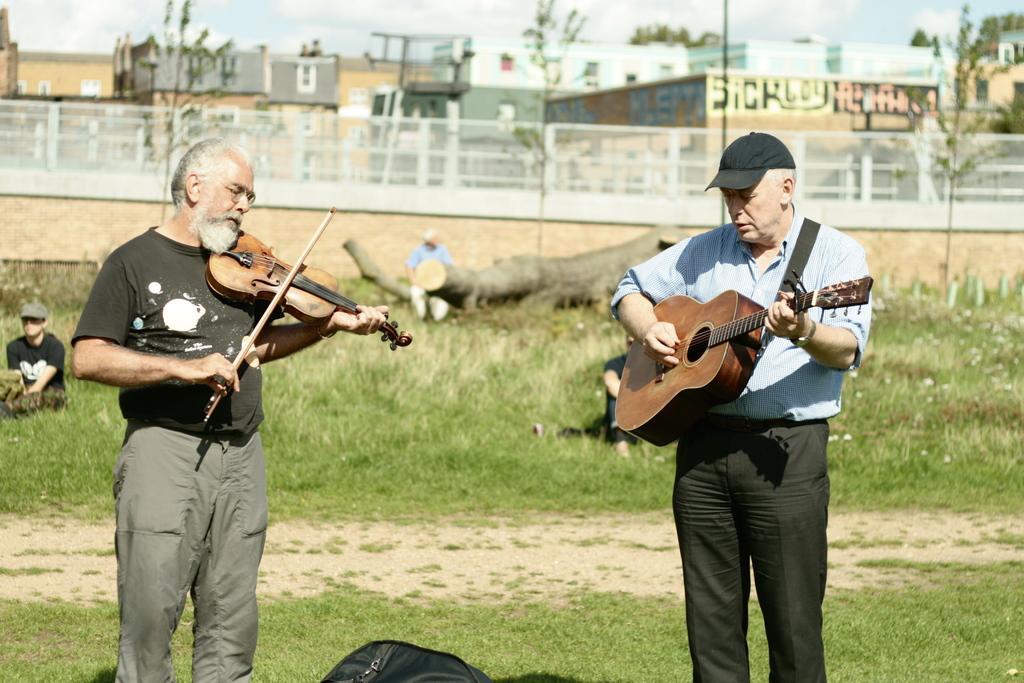In one or two sentences, can you explain what this image depicts? This picture is of outside. On the right there is a man wearing blue color shirt, standing and playing guitar. On the left there is a man wearing black color t-shirt, standing and playing violin. In the background we can see the ground full of grass and the trunk of a tree. There is a person sitting on the trunk of a tree and there is a person wearing black color t-shirt and sitting on the ground and we can see the sky, buildings and trees. 